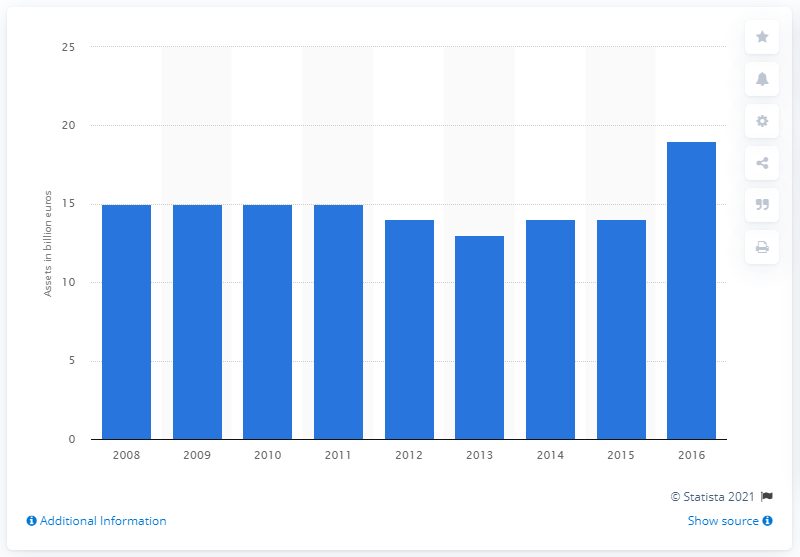Mention a couple of crucial points in this snapshot. In 2016, the value of Slovenia's foreign-controlled banking group subsidiaries and branches was 19... 